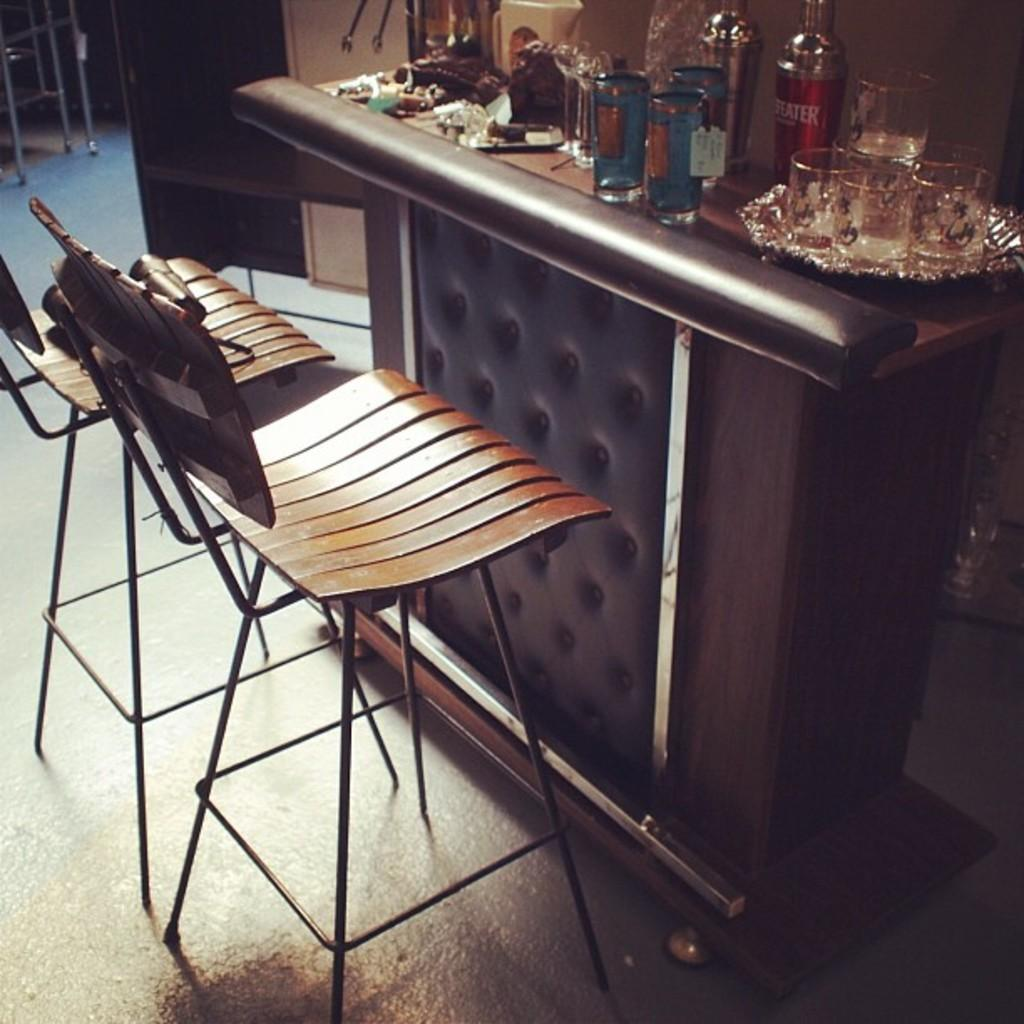How many chairs are in the image? There are two chairs in the image. What is the primary piece of furniture in the image? There is a table in the image. What can be seen on the table? There are glasses, bottles, and a plate on the table. Are there any other objects on the table? Yes, there are other objects on the table. What is visible on the floor in the image? There are objects on the floor in the image. Can you tell me how many mines are present in the image? There are no mines present in the image. What type of drain is visible in the image? There is no drain present in the image. 